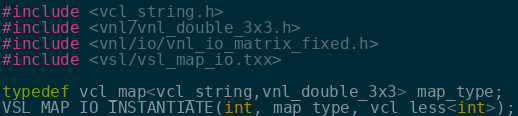<code> <loc_0><loc_0><loc_500><loc_500><_C++_>#include <vcl_string.h>
#include <vnl/vnl_double_3x3.h>
#include <vnl/io/vnl_io_matrix_fixed.h>
#include <vsl/vsl_map_io.txx>
 
typedef vcl_map<vcl_string,vnl_double_3x3> map_type;
VSL_MAP_IO_INSTANTIATE(int, map_type, vcl_less<int>);
</code> 